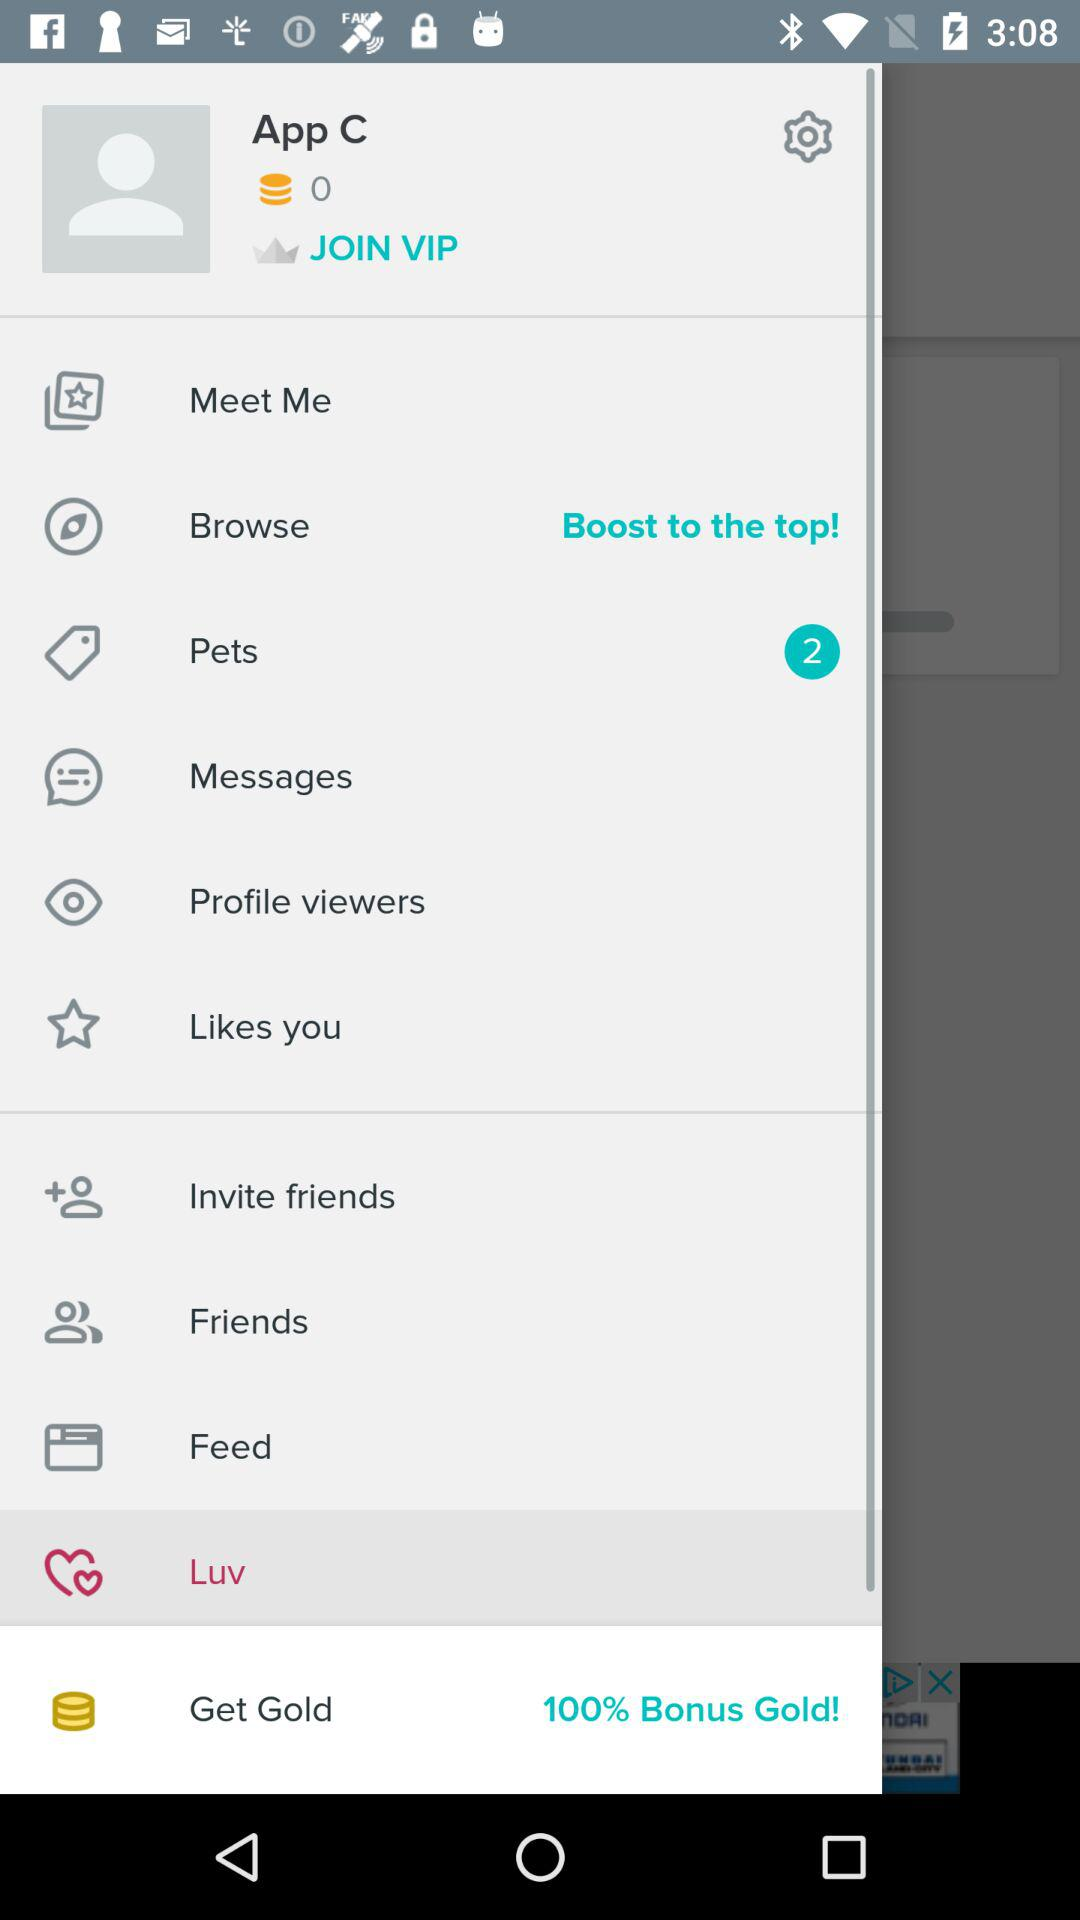How many unread messages are there?
When the provided information is insufficient, respond with <no answer>. <no answer> 